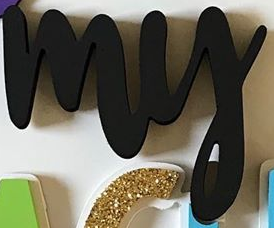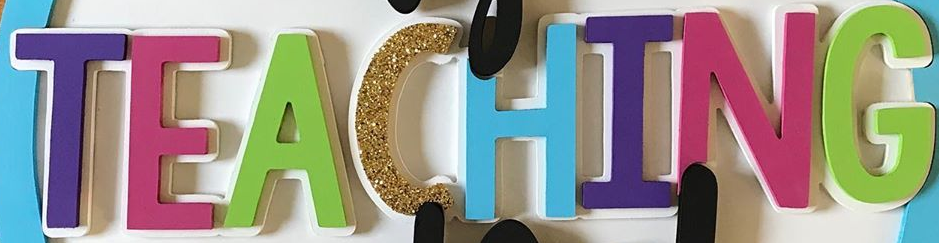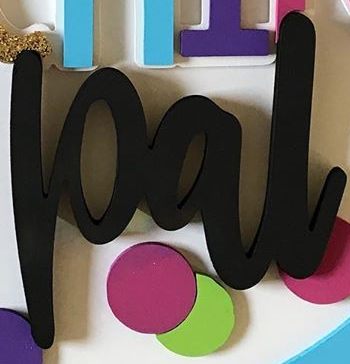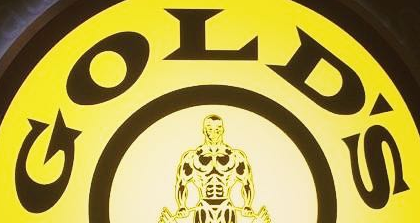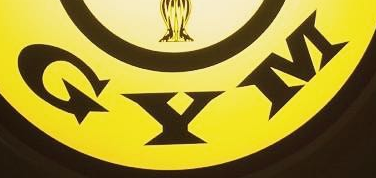Read the text from these images in sequence, separated by a semicolon. my; TEACHING; pal; GOLD'S; GYM 